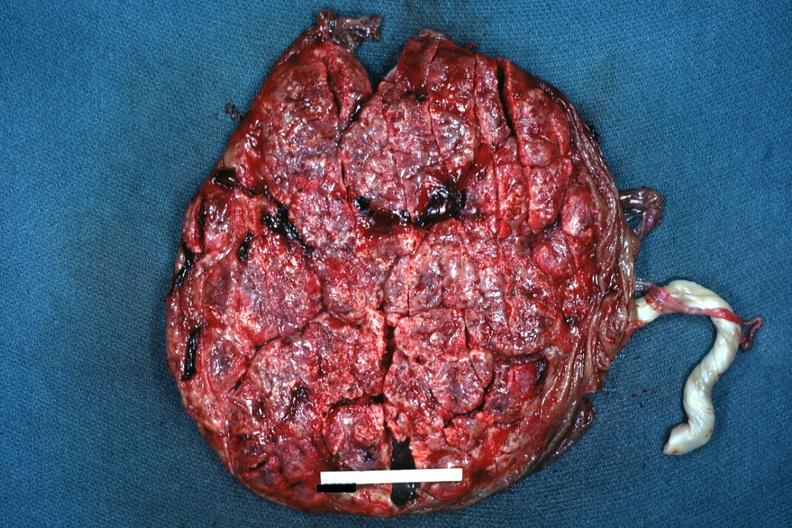s quite good liver present?
Answer the question using a single word or phrase. No 